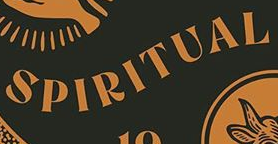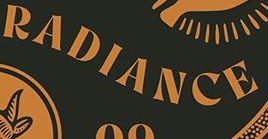Identify the words shown in these images in order, separated by a semicolon. SPIRITUAL; RADIANCE 